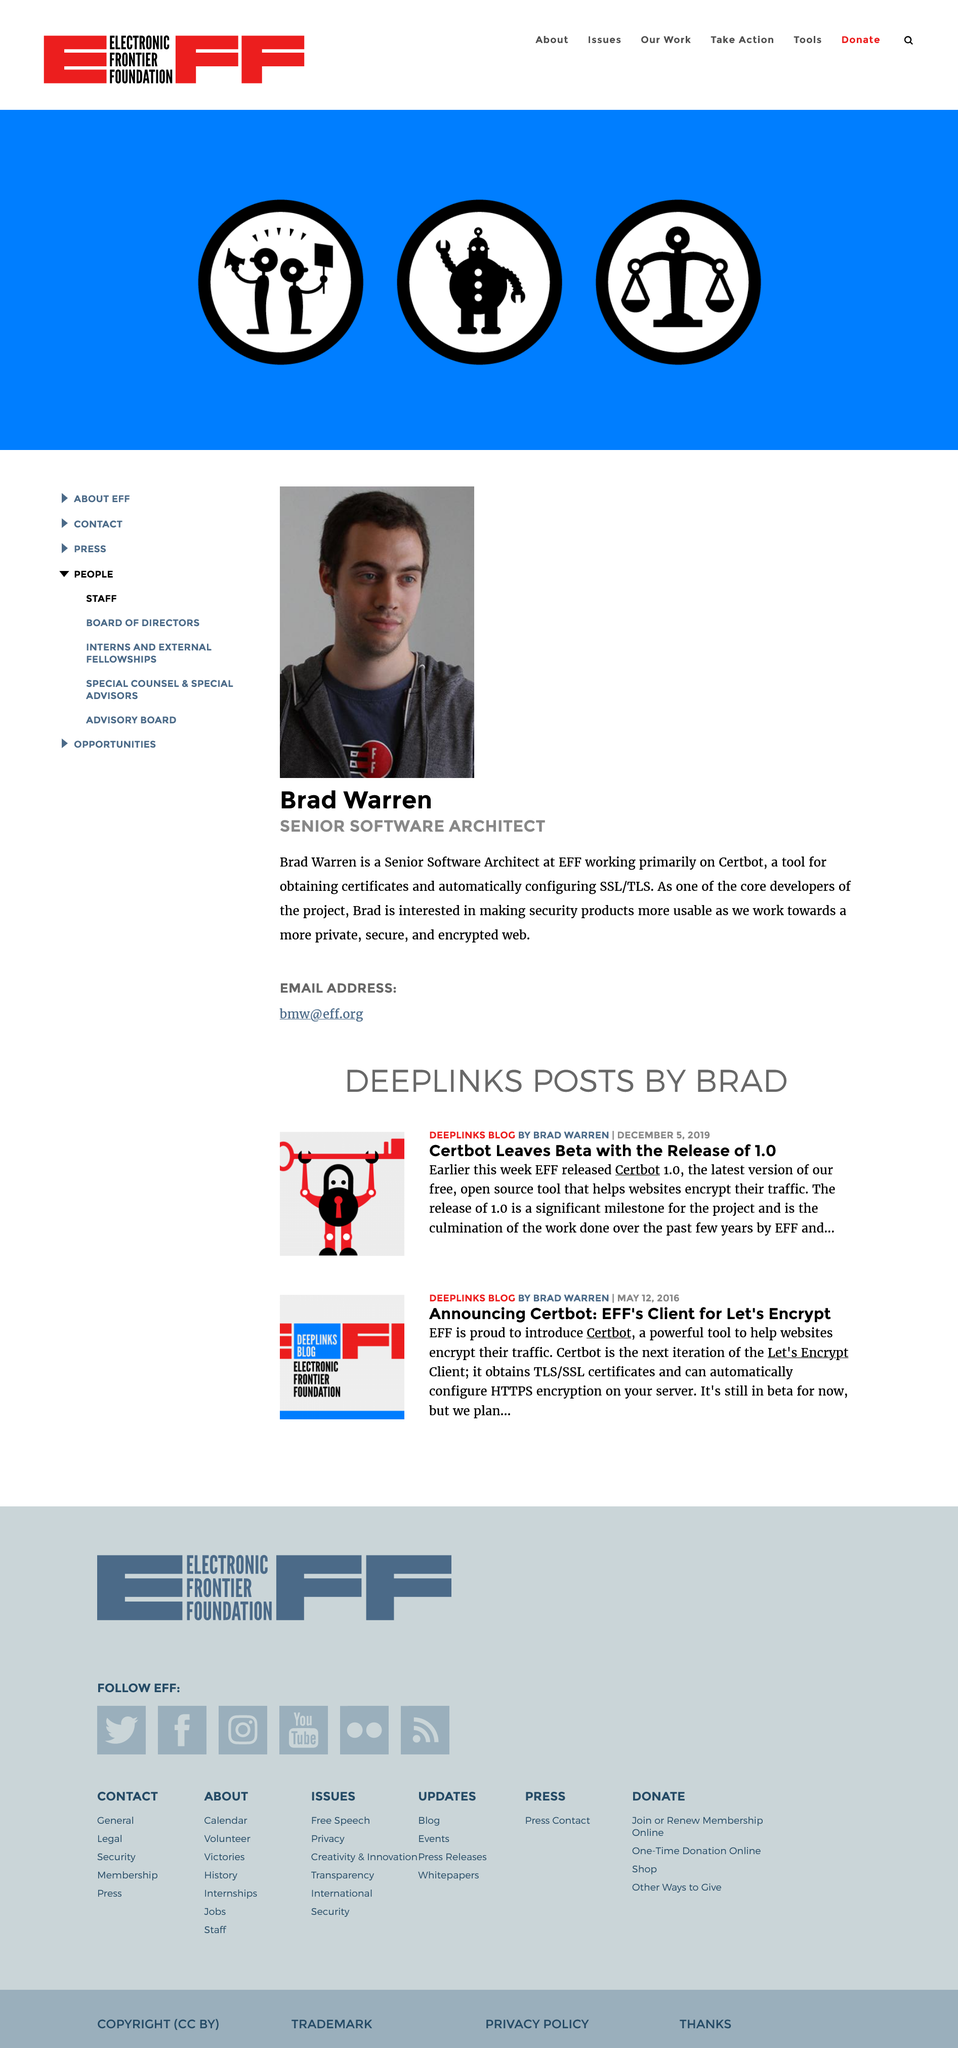Specify some key components in this picture. Brad Warren is the Senior Architect at the Electronic Frontier Foundation (EFF) and serves as the Senior Software Architect. The email address for Brad Warren, a Senior Software Architect at the Electronic Frontier Foundation (EFF), is [bmw@eff.org](mailto:bmw@eff.org). Brad Warren is primarily working on Cerbot, a tool for obtaining certificates and automatically configuring SSL/TLS on websites, as part of his work for the Electronic Frontier Foundation (EFF). 